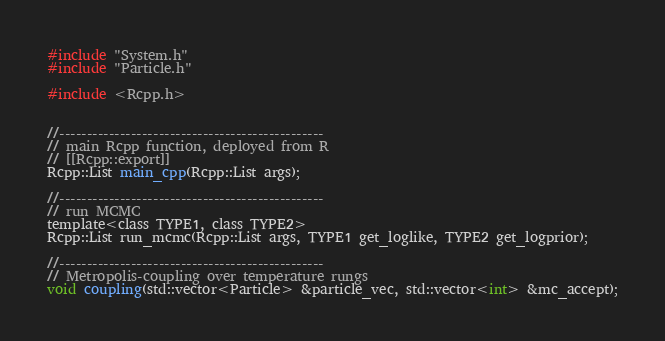<code> <loc_0><loc_0><loc_500><loc_500><_C_>
#include "System.h"
#include "Particle.h"

#include <Rcpp.h>


//------------------------------------------------
// main Rcpp function, deployed from R
// [[Rcpp::export]]
Rcpp::List main_cpp(Rcpp::List args);

//------------------------------------------------
// run MCMC
template<class TYPE1, class TYPE2>
Rcpp::List run_mcmc(Rcpp::List args, TYPE1 get_loglike, TYPE2 get_logprior);

//------------------------------------------------
// Metropolis-coupling over temperature rungs
void coupling(std::vector<Particle> &particle_vec, std::vector<int> &mc_accept);
</code> 